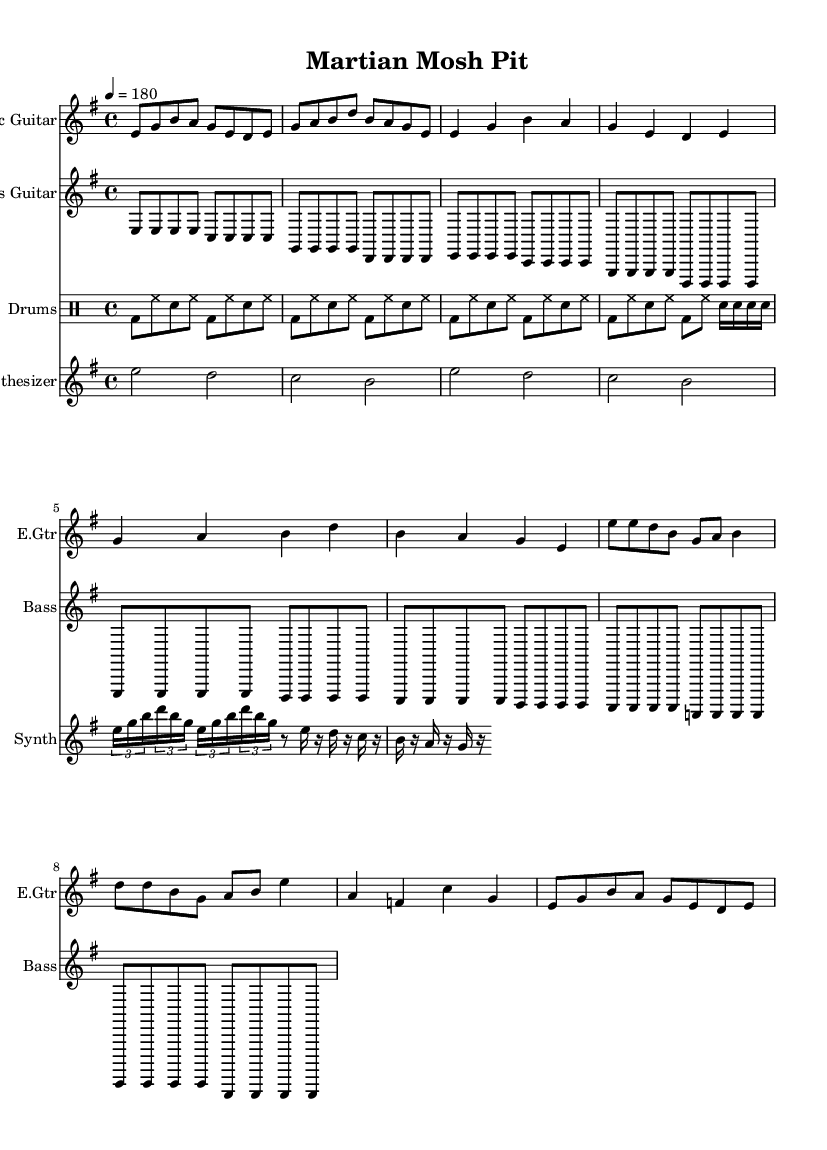What is the key signature of this music? The key signature is E minor, which is indicated by one sharp (F♯) in the key signature area.
Answer: E minor What is the time signature of this music? The time signature is 4/4, which is shown at the beginning of the score with the fraction indicating four beats per measure.
Answer: 4/4 What is the tempo marking of this music? The tempo marking indicates a speed of 180 beats per minute, noted in the score by the term "4 = 180" placed above the staff.
Answer: 180 How many measures are in the intro section? The intro section consists of 2 measures, as counted by the number of vertical bar lines occurring before the verse.
Answer: 2 What is the main type of beat used in the drums part? The main type of beat is a basic punk rock beat, characterized by the repeated bass drum and snare drum pattern throughout the piece.
Answer: Basic punk rock beat How many notes are in the synthesizer’s laser-like arpeggio? The synthesizer's laser-like arpeggio contains 12 notes, as determined by counting each individual note within the tuplets in that section.
Answer: 12 Which instrument has the longest note duration overall? The synthesizer has the longest note duration overall, as seen with its whole notes and half notes that sustain over multiple beats.
Answer: Synthesizer 